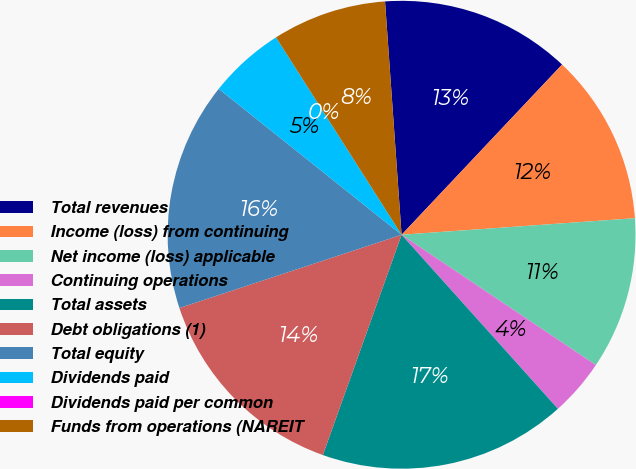<chart> <loc_0><loc_0><loc_500><loc_500><pie_chart><fcel>Total revenues<fcel>Income (loss) from continuing<fcel>Net income (loss) applicable<fcel>Continuing operations<fcel>Total assets<fcel>Debt obligations (1)<fcel>Total equity<fcel>Dividends paid<fcel>Dividends paid per common<fcel>Funds from operations (NAREIT<nl><fcel>13.16%<fcel>11.84%<fcel>10.53%<fcel>3.95%<fcel>17.11%<fcel>14.47%<fcel>15.79%<fcel>5.26%<fcel>0.0%<fcel>7.89%<nl></chart> 